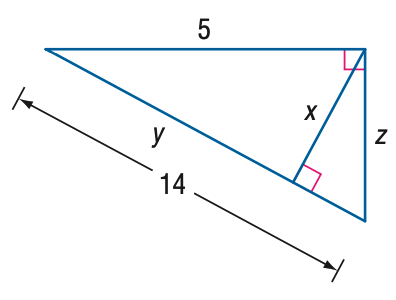Answer the mathemtical geometry problem and directly provide the correct option letter.
Question: Find y.
Choices: A: \frac { 5 } { 14 } B: \frac { 25 } { 14 } C: 5 D: \frac { 171 } { 14 } B 